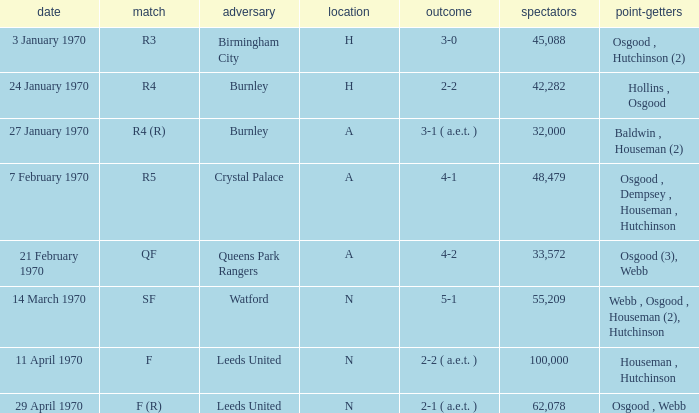Write the full table. {'header': ['date', 'match', 'adversary', 'location', 'outcome', 'spectators', 'point-getters'], 'rows': [['3 January 1970', 'R3', 'Birmingham City', 'H', '3-0', '45,088', 'Osgood , Hutchinson (2)'], ['24 January 1970', 'R4', 'Burnley', 'H', '2-2', '42,282', 'Hollins , Osgood'], ['27 January 1970', 'R4 (R)', 'Burnley', 'A', '3-1 ( a.e.t. )', '32,000', 'Baldwin , Houseman (2)'], ['7 February 1970', 'R5', 'Crystal Palace', 'A', '4-1', '48,479', 'Osgood , Dempsey , Houseman , Hutchinson'], ['21 February 1970', 'QF', 'Queens Park Rangers', 'A', '4-2', '33,572', 'Osgood (3), Webb'], ['14 March 1970', 'SF', 'Watford', 'N', '5-1', '55,209', 'Webb , Osgood , Houseman (2), Hutchinson'], ['11 April 1970', 'F', 'Leeds United', 'N', '2-2 ( a.e.t. )', '100,000', 'Houseman , Hutchinson'], ['29 April 1970', 'F (R)', 'Leeds United', 'N', '2-1 ( a.e.t. )', '62,078', 'Osgood , Webb']]} In what round did the game with watford take place? SF. 